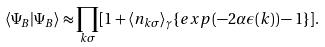Convert formula to latex. <formula><loc_0><loc_0><loc_500><loc_500>\langle \Psi _ { B } | \Psi _ { B } \rangle \approx \prod _ { { k } \sigma } [ 1 + \langle n _ { { k } \sigma } \rangle _ { \gamma } \{ e x p ( - 2 \alpha \epsilon ( { k } ) ) - 1 \} ] .</formula> 